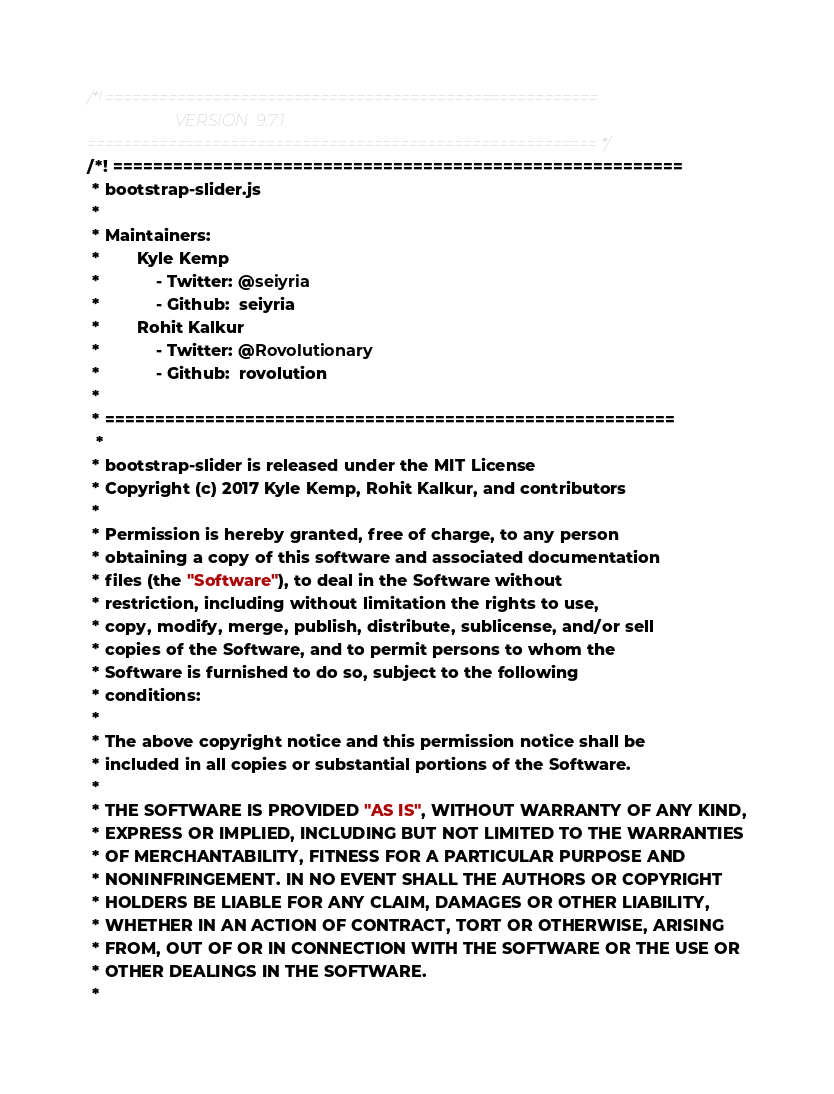<code> <loc_0><loc_0><loc_500><loc_500><_CSS_>/*! =======================================================
                      VERSION  9.7.1              
========================================================= */
/*! =========================================================
 * bootstrap-slider.js
 *
 * Maintainers:
 *		Kyle Kemp
 *			- Twitter: @seiyria
 *			- Github:  seiyria
 *		Rohit Kalkur
 *			- Twitter: @Rovolutionary
 *			- Github:  rovolution
 *
 * =========================================================
  *
 * bootstrap-slider is released under the MIT License
 * Copyright (c) 2017 Kyle Kemp, Rohit Kalkur, and contributors
 * 
 * Permission is hereby granted, free of charge, to any person
 * obtaining a copy of this software and associated documentation
 * files (the "Software"), to deal in the Software without
 * restriction, including without limitation the rights to use,
 * copy, modify, merge, publish, distribute, sublicense, and/or sell
 * copies of the Software, and to permit persons to whom the
 * Software is furnished to do so, subject to the following
 * conditions:
 * 
 * The above copyright notice and this permission notice shall be
 * included in all copies or substantial portions of the Software.
 * 
 * THE SOFTWARE IS PROVIDED "AS IS", WITHOUT WARRANTY OF ANY KIND,
 * EXPRESS OR IMPLIED, INCLUDING BUT NOT LIMITED TO THE WARRANTIES
 * OF MERCHANTABILITY, FITNESS FOR A PARTICULAR PURPOSE AND
 * NONINFRINGEMENT. IN NO EVENT SHALL THE AUTHORS OR COPYRIGHT
 * HOLDERS BE LIABLE FOR ANY CLAIM, DAMAGES OR OTHER LIABILITY,
 * WHETHER IN AN ACTION OF CONTRACT, TORT OR OTHERWISE, ARISING
 * FROM, OUT OF OR IN CONNECTION WITH THE SOFTWARE OR THE USE OR
 * OTHER DEALINGS IN THE SOFTWARE.
 *</code> 